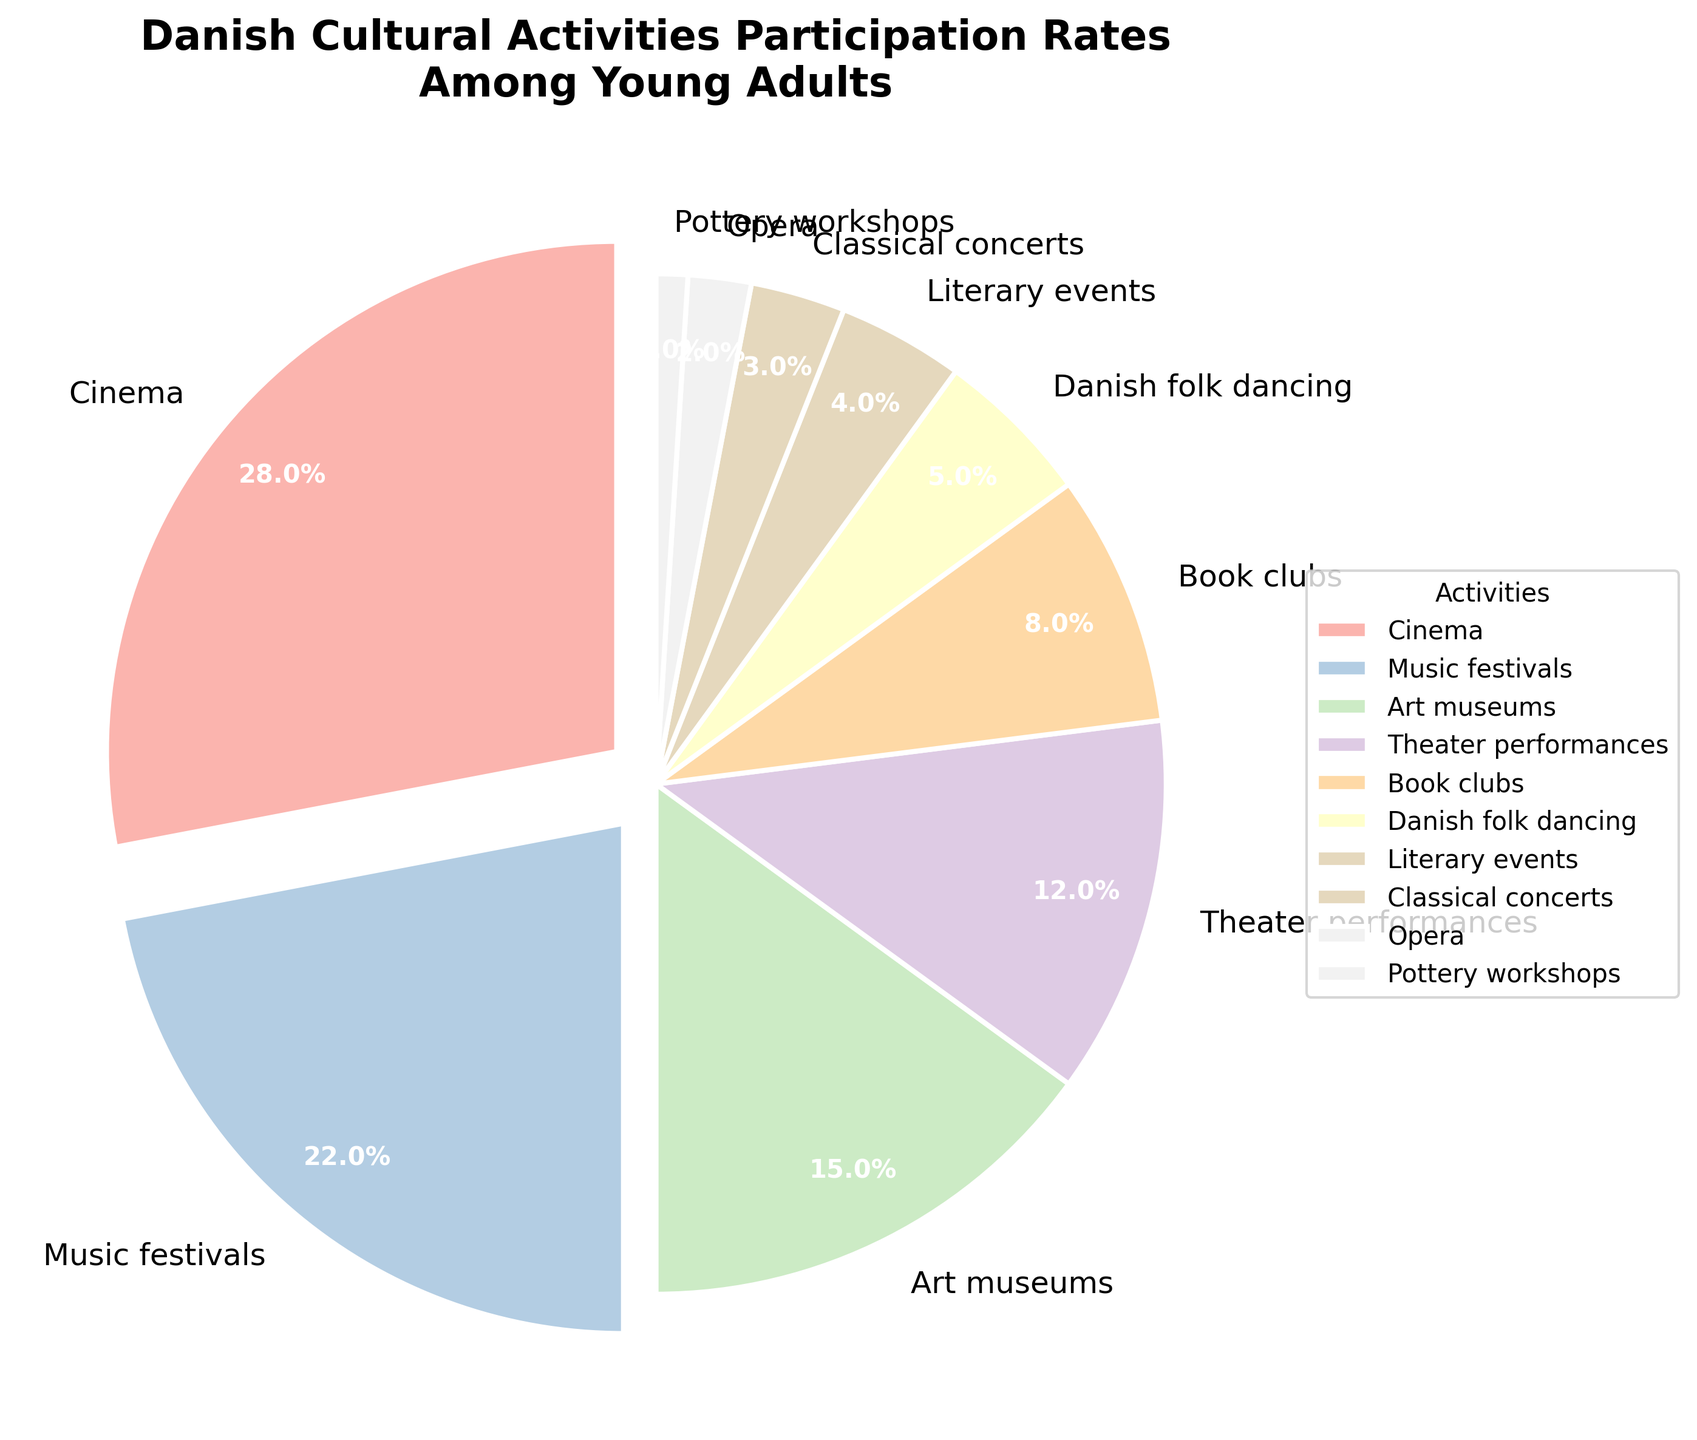What's the most popular cultural activity among young Danish adults? The most popular activity can be identified as the one with the largest percentage. According to the pie chart, the activity with the highest percentage is Cinema at 28%.
Answer: Cinema Which activity has the lowest participation rate? Look for the smallest percentage on the pie chart. The activity with the lowest participation rate is Pottery workshops at 1%.
Answer: Pottery workshops What is the total percentage of young adults participating in Music festivals, Theater performances, and Opera combined? Sum the percentages of these three activities: Music festivals (22%), Theater performances (12%), and Opera (2%). So, 22 + 12 + 2 = 36% total.
Answer: 36% How does the participation rate for Classical concerts compare to that of Art museums? Compare the percentages of the two activities: Classical concerts are at 3% and Art museums are at 15%. Classical concerts have a lower participation rate.
Answer: Classical concerts have a lower rate What is the combined participation rate of activities with a percentage less than 5%? Add the percentages of activities with less than 5% participation: Danish folk dancing (5%), Literary events (4%), Classical concerts (3%), Opera (2%), and Pottery workshops (1%). So, 5 + 4 + 3 + 2 + 1 = 15%.
Answer: 15% What visual feature highlights the top activity on the pie chart? The pie chart uses an "explode" feature to emphasize the biggest slices. Cinema, being the top activity, is slightly separated (exploded) from the rest of the pie.
Answer: Exploded slice Which activities have an "explode" effect applied to them and why? The "explode" effect is used on activities with a percentage higher than 15%. According to the data, only Cinema (28%) and Music festivals (22%) have this effect applied.
Answer: Cinema and Music festivals Are there more young adults participating in Book clubs or Danish folk dancing? Compare the percentages: Book clubs have 8%, whereas Danish folk dancing has 5%. Therefore, more young adults participate in Book clubs.
Answer: Book clubs What's the percentage difference between participants of Music festivals and Theater performances? Subtract the percentage of Theater performances from Music festivals: 22% - 12% = 10%.
Answer: 10% Which activity holds a middle (median) position in terms of participation? List the activities by increasing order of participation: Pottery workshops (1%), Opera (2%), Classical concerts (3%), Literary events (4%), Danish folk dancing (5%), Book clubs (8%), Theater performances (12%), Art museums (15%), Music festivals (22%), Cinema (28%). The middle value for 10 activities is the average of the 5th and 6th: (5+8)/2 = 6.5%, which corresponds to Danish folk dancing and Book clubs.
Answer: Danish folk dancing and Book clubs 